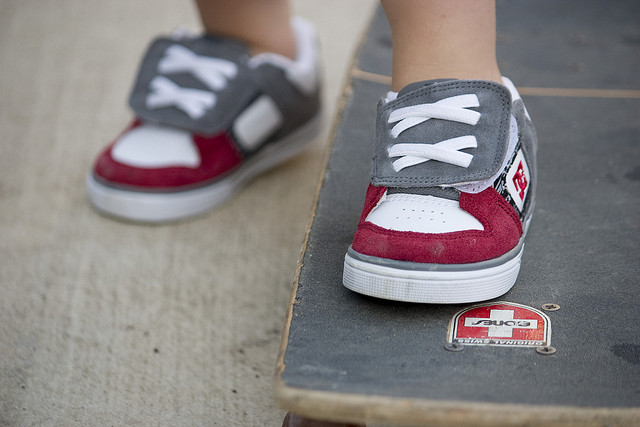<image>What size shoe are they? I don't know what size shoe they are. There are several different responses such as '1', '3', '3c', '4', '6', and '8'. What size shoe are they? I don't know the size of their shoe. It can be seen somewhere between '1', 'kids', 'unknown', '3', '3c', '1', '4', '6', '3', '8'. 